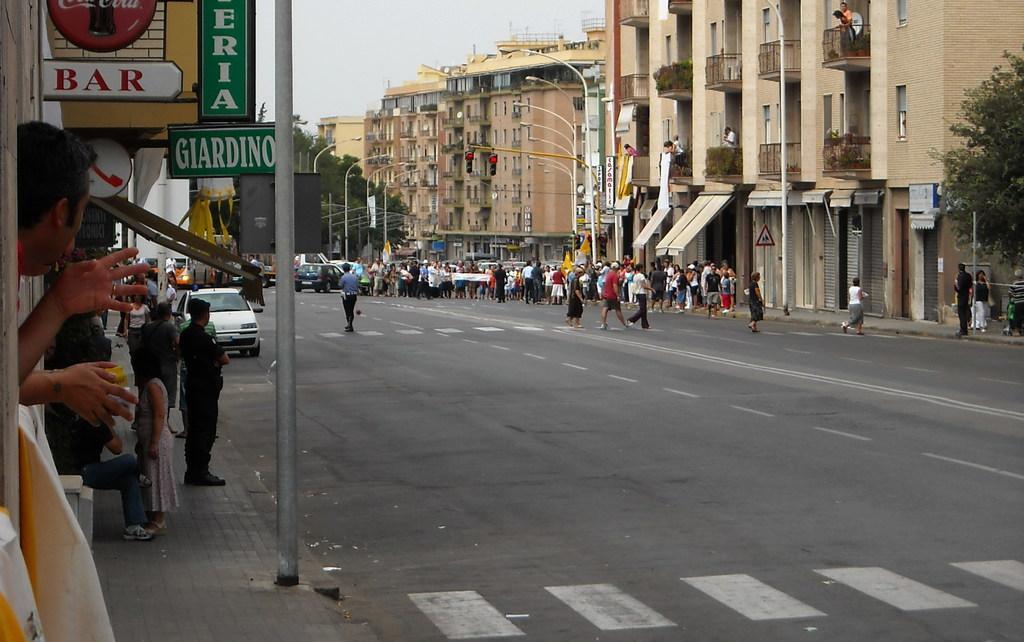Please provide a concise description of this image. In this picture we can see the view of the road. In the front there is a group of men and women standing for the protest. On the right corner there are brown color buildings, street light, traffic signals. On the left corner we can see bar shops and some other shops. In the front there are some persons standing on the footpath area. 